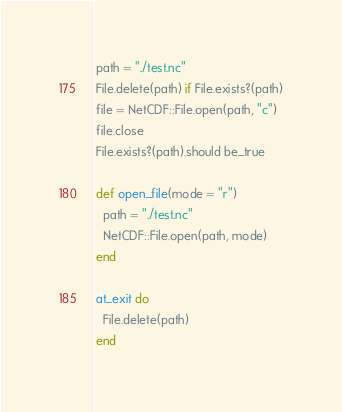Convert code to text. <code><loc_0><loc_0><loc_500><loc_500><_Crystal_>path = "./test.nc"
File.delete(path) if File.exists?(path)
file = NetCDF::File.open(path, "c")
file.close
File.exists?(path).should be_true

def open_file(mode = "r")
  path = "./test.nc"
  NetCDF::File.open(path, mode)
end

at_exit do
  File.delete(path)
end
</code> 